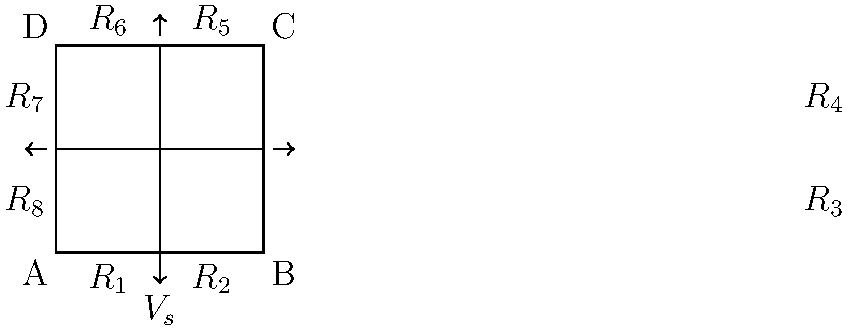Given the circuit diagram above, where all resistors have a value of 10 Ω and the voltage source $V_s$ is 12 V, determine the current flowing through resistor $R_3$ using Kirchhoff's laws. Assume the current directions are as indicated by the arrows in the diagram. To solve this problem using Kirchhoff's laws, we'll follow these steps:

1) First, let's identify the loops and nodes in the circuit. We have 4 main nodes (A, B, C, D) and 4 loops.

2) Apply Kirchhoff's Voltage Law (KVL) to the outer loop:
   $$V_s - I_1R_1 - I_1R_2 - I_2R_3 - I_2R_4 - I_3R_5 - I_3R_6 - I_4R_7 - I_4R_8 = 0$$

3) Apply KVL to the top-right loop:
   $$I_2R_3 + I_2R_4 - I_5R_5 - I_5R_6 = 0$$

4) Apply KVL to the bottom-right loop:
   $$I_1R_2 + I_2R_3 - I_5R_3 - I_5R_4 = 0$$

5) Apply Kirchhoff's Current Law (KCL) at node B:
   $$I_1 = I_2 + I_5$$

6) Apply KCL at node D:
   $$I_3 = I_4 + I_5$$

7) Due to symmetry, we can deduce that $I_1 = I_3$ and $I_2 = I_4$

8) Substituting the known values (R = 10 Ω, $V_s$ = 12 V) into the equations:

   12 - 20$I_1$ - 20$I_2$ - 20$I_3$ - 20$I_4$ = 0
   20$I_2$ - 20$I_5$ = 0
   10$I_1$ + 10$I_2$ - 20$I_5$ = 0
   $I_1$ = $I_2$ + $I_5$
   $I_3$ = $I_4$ + $I_5$
   $I_1$ = $I_3$
   $I_2$ = $I_4$

9) Solving this system of equations (which can be done using a computer algebra system or matrix methods), we get:

   $I_1 = I_3 = 0.3$ A
   $I_2 = I_4 = 0.2$ A
   $I_5 = 0.1$ A

10) The current through $R_3$ is $I_2$, which is 0.2 A.
Answer: 0.2 A 